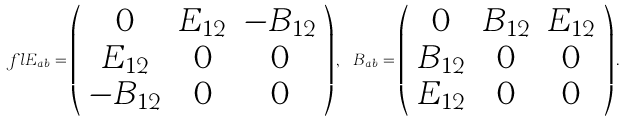<formula> <loc_0><loc_0><loc_500><loc_500>\ f l E _ { a b } = \left ( \begin{array} { c c c } 0 & E _ { 1 2 } & - B _ { 1 2 } \\ E _ { 1 2 } & 0 & 0 \\ - B _ { 1 2 } & 0 & 0 \end{array} \right ) , \ B _ { a b } = \left ( \begin{array} { c c c } 0 & B _ { 1 2 } & E _ { 1 2 } \\ B _ { 1 2 } & 0 & 0 \\ E _ { 1 2 } & 0 & 0 \end{array} \right ) .</formula> 